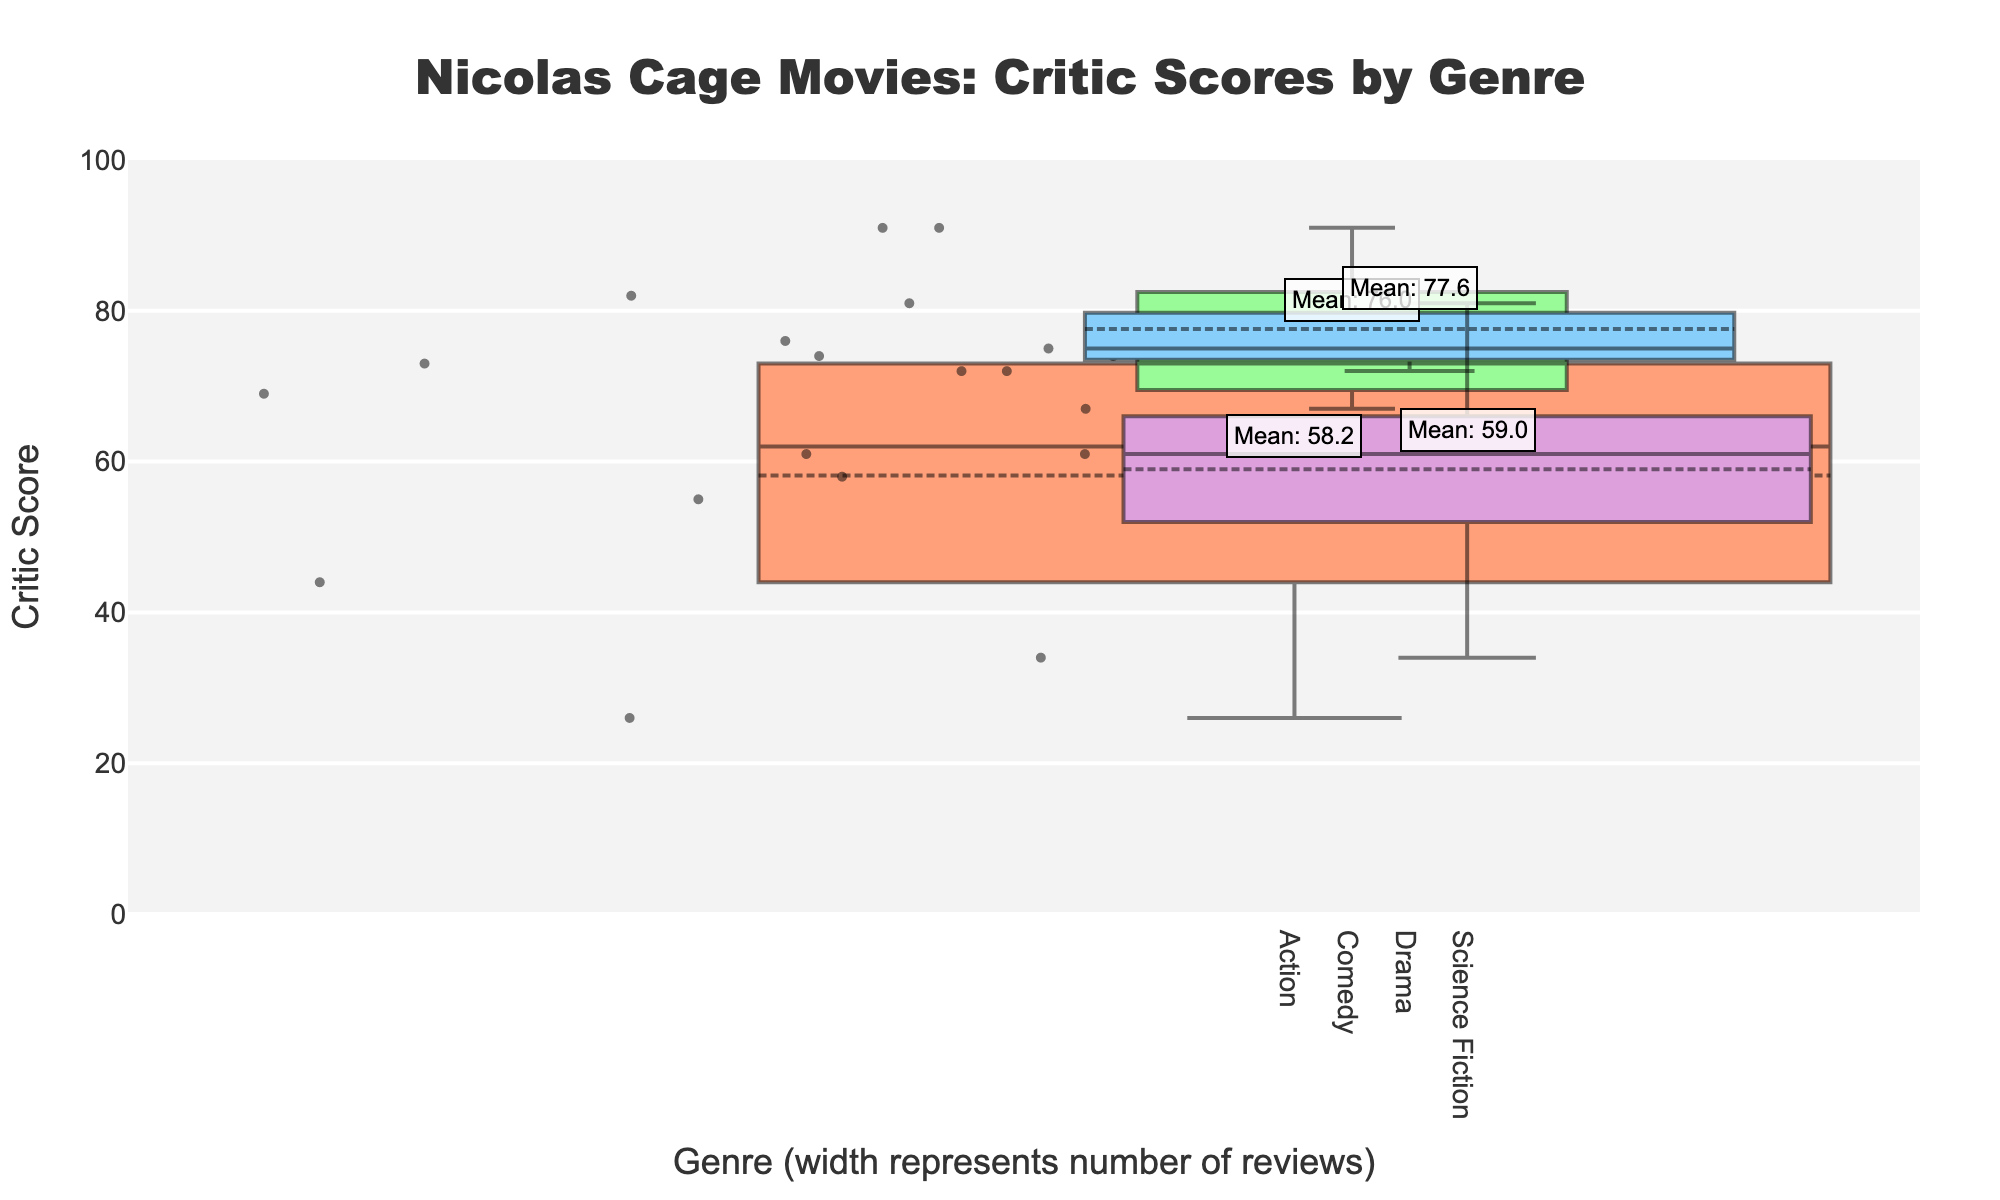What is the title of the figure? The title is displayed at the top of the figure and reads "Nicolas Cage Movies: Critic Scores by Genre".
Answer: Nicolas Cage Movies: Critic Scores by Genre Which genre has the widest box plot? The width of the box plots represents the number of reviews. The genre with the widest box plot has the highest total number of reviews.
Answer: Action What is the median score for Drama movies? The median score is the middle point of the box plot for Drama. By looking at the box plot for Drama, we can find the median score.
Answer: Approximately 74 Which genre has the highest mean score? Each genre's mean score is annotated on the plot. By examining these annotations, we identify the genre with the highest mean score.
Answer: Comedy Which genre has the lowest minimum critic score? The minimum score is represented by the lower whisker of each box plot. By observing the lowest whiskers, we can determine that Science Fiction has the lowest minimum score.
Answer: Science Fiction What is the range of critic scores for Action movies? The range is the difference between the maximum and minimum scores. Observing the top and bottom of the Action box plot provides this information.
Answer: 26 to 82 Compare the maximum scores of Comedy and Drama movies. Which one is higher? By looking at the top whiskers of the Comedy and Drama box plots, we can compare the maximum scores directly.
Answer: Comedy Which genre has a mean closer to its median, Action or Drama? Comparing the median and mean annotations for both Action and Drama will reveal which genre has a closer mean to its median.
Answer: Drama What is the total number of reviews for Science Fiction movies? The width of each box plot represents the total number of reviews. Science Fiction's width and corresponding review sum can be used to determine this.
Answer: 597 How does the mean score for Action compare to the mean score for Comedy? By reading the mean annotations for both Action and Comedy, we can specifically compare their values to see which is higher.
Answer: Comedy is higher than Action 